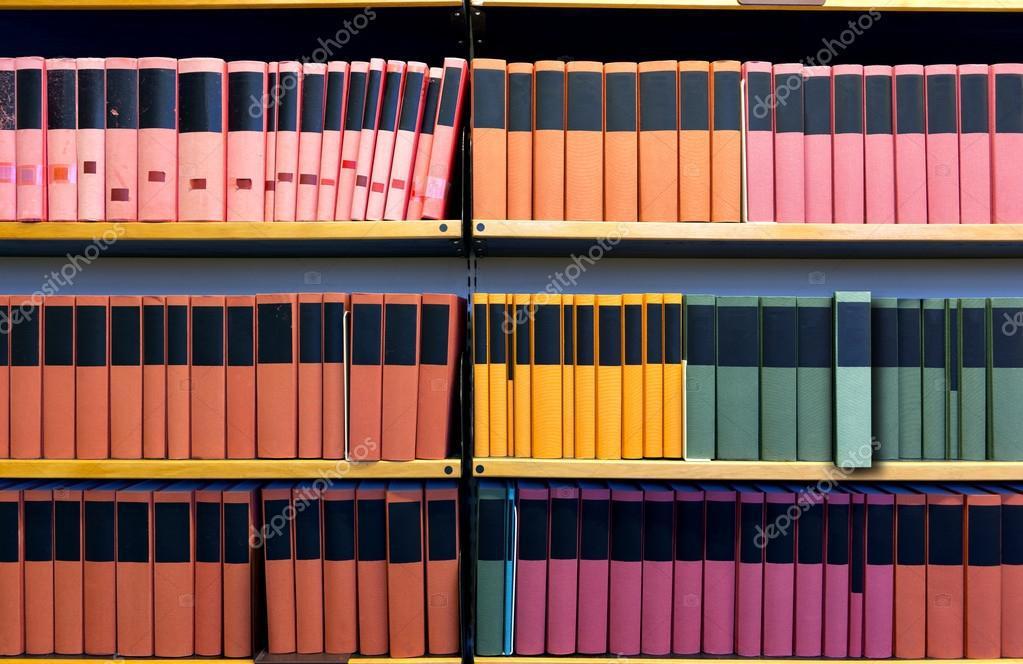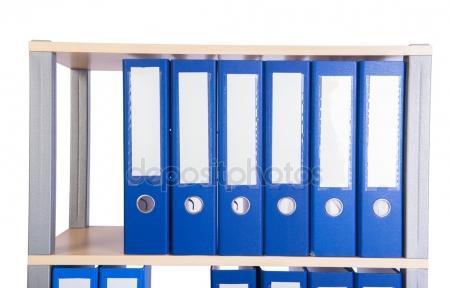The first image is the image on the left, the second image is the image on the right. Assess this claim about the two images: "An image shows one row of colored folders with rectangular white labels on the binding.". Correct or not? Answer yes or no. Yes. 